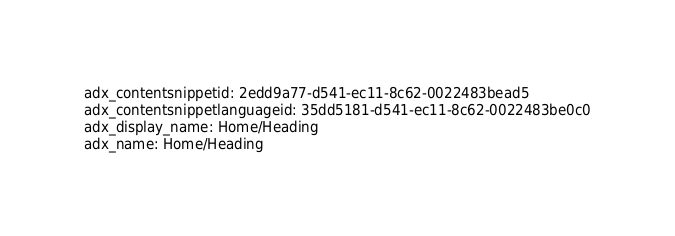<code> <loc_0><loc_0><loc_500><loc_500><_YAML_>adx_contentsnippetid: 2edd9a77-d541-ec11-8c62-0022483bead5
adx_contentsnippetlanguageid: 35dd5181-d541-ec11-8c62-0022483be0c0
adx_display_name: Home/Heading
adx_name: Home/Heading
</code> 